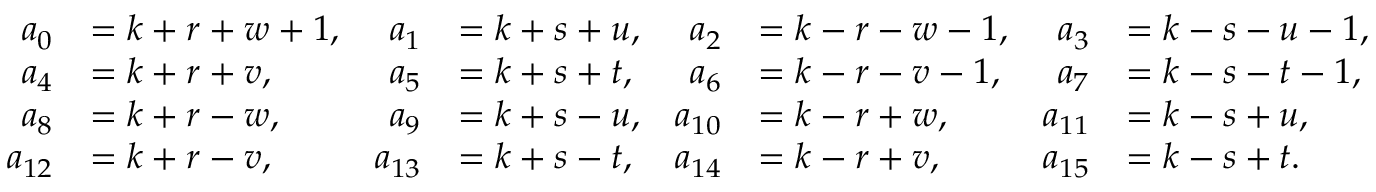<formula> <loc_0><loc_0><loc_500><loc_500>\begin{array} { r l r l r l r l } { a _ { 0 } } & { = k + r + w + 1 , } & { a _ { 1 } } & { = k + s + u , } & { a _ { 2 } } & { = k - r - w - 1 , } & { a _ { 3 } } & { = k - s - u - 1 , } \\ { a _ { 4 } } & { = k + r + v , } & { a _ { 5 } } & { = k + s + t , } & { a _ { 6 } } & { = k - r - v - 1 , } & { a _ { 7 } } & { = k - s - t - 1 , } \\ { a _ { 8 } } & { = k + r - w , } & { a _ { 9 } } & { = k + s - u , } & { a _ { 1 0 } } & { = k - r + w , } & { a _ { 1 1 } } & { = k - s + u , } \\ { a _ { 1 2 } } & { = k + r - v , } & { a _ { 1 3 } } & { = k + s - t , } & { a _ { 1 4 } } & { = k - r + v , } & { a _ { 1 5 } } & { = k - s + t . } \end{array}</formula> 